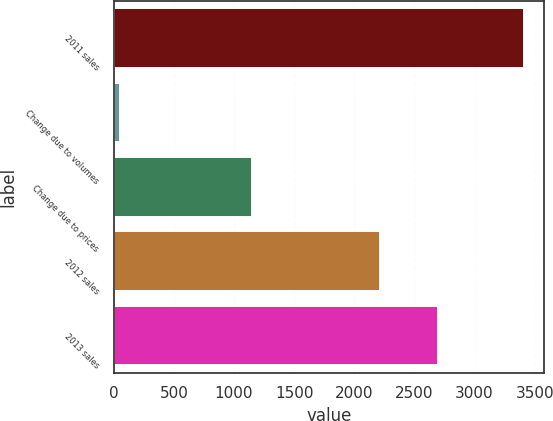Convert chart to OTSL. <chart><loc_0><loc_0><loc_500><loc_500><bar_chart><fcel>2011 sales<fcel>Change due to volumes<fcel>Change due to prices<fcel>2012 sales<fcel>2013 sales<nl><fcel>3411<fcel>52<fcel>1148<fcel>2211<fcel>2698<nl></chart> 